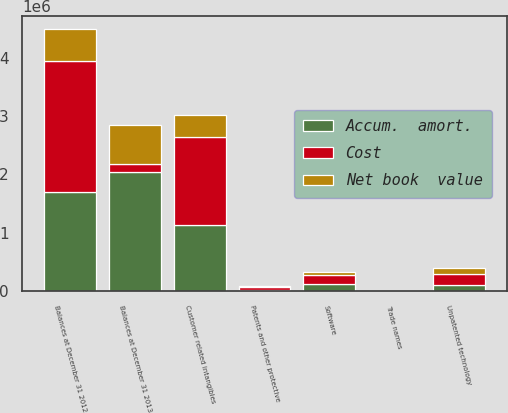Convert chart to OTSL. <chart><loc_0><loc_0><loc_500><loc_500><stacked_bar_chart><ecel><fcel>Customer related intangibles<fcel>Unpatented technology<fcel>Software<fcel>Patents and other protective<fcel>Balances at December 31 2012<fcel>Trade names<fcel>Balances at December 31 2013<nl><fcel>Cost<fcel>1.50934e+06<fcel>198609<fcel>160520<fcel>40399<fcel>2.24196e+06<fcel>656<fcel>138392<nl><fcel>Net book  value<fcel>379535<fcel>97487<fcel>44256<fcel>20312<fcel>543090<fcel>16<fcel>664131<nl><fcel>Accum.  amort.<fcel>1.1298e+06<fcel>101122<fcel>116264<fcel>20087<fcel>1.69887e+06<fcel>640<fcel>2.03914e+06<nl></chart> 